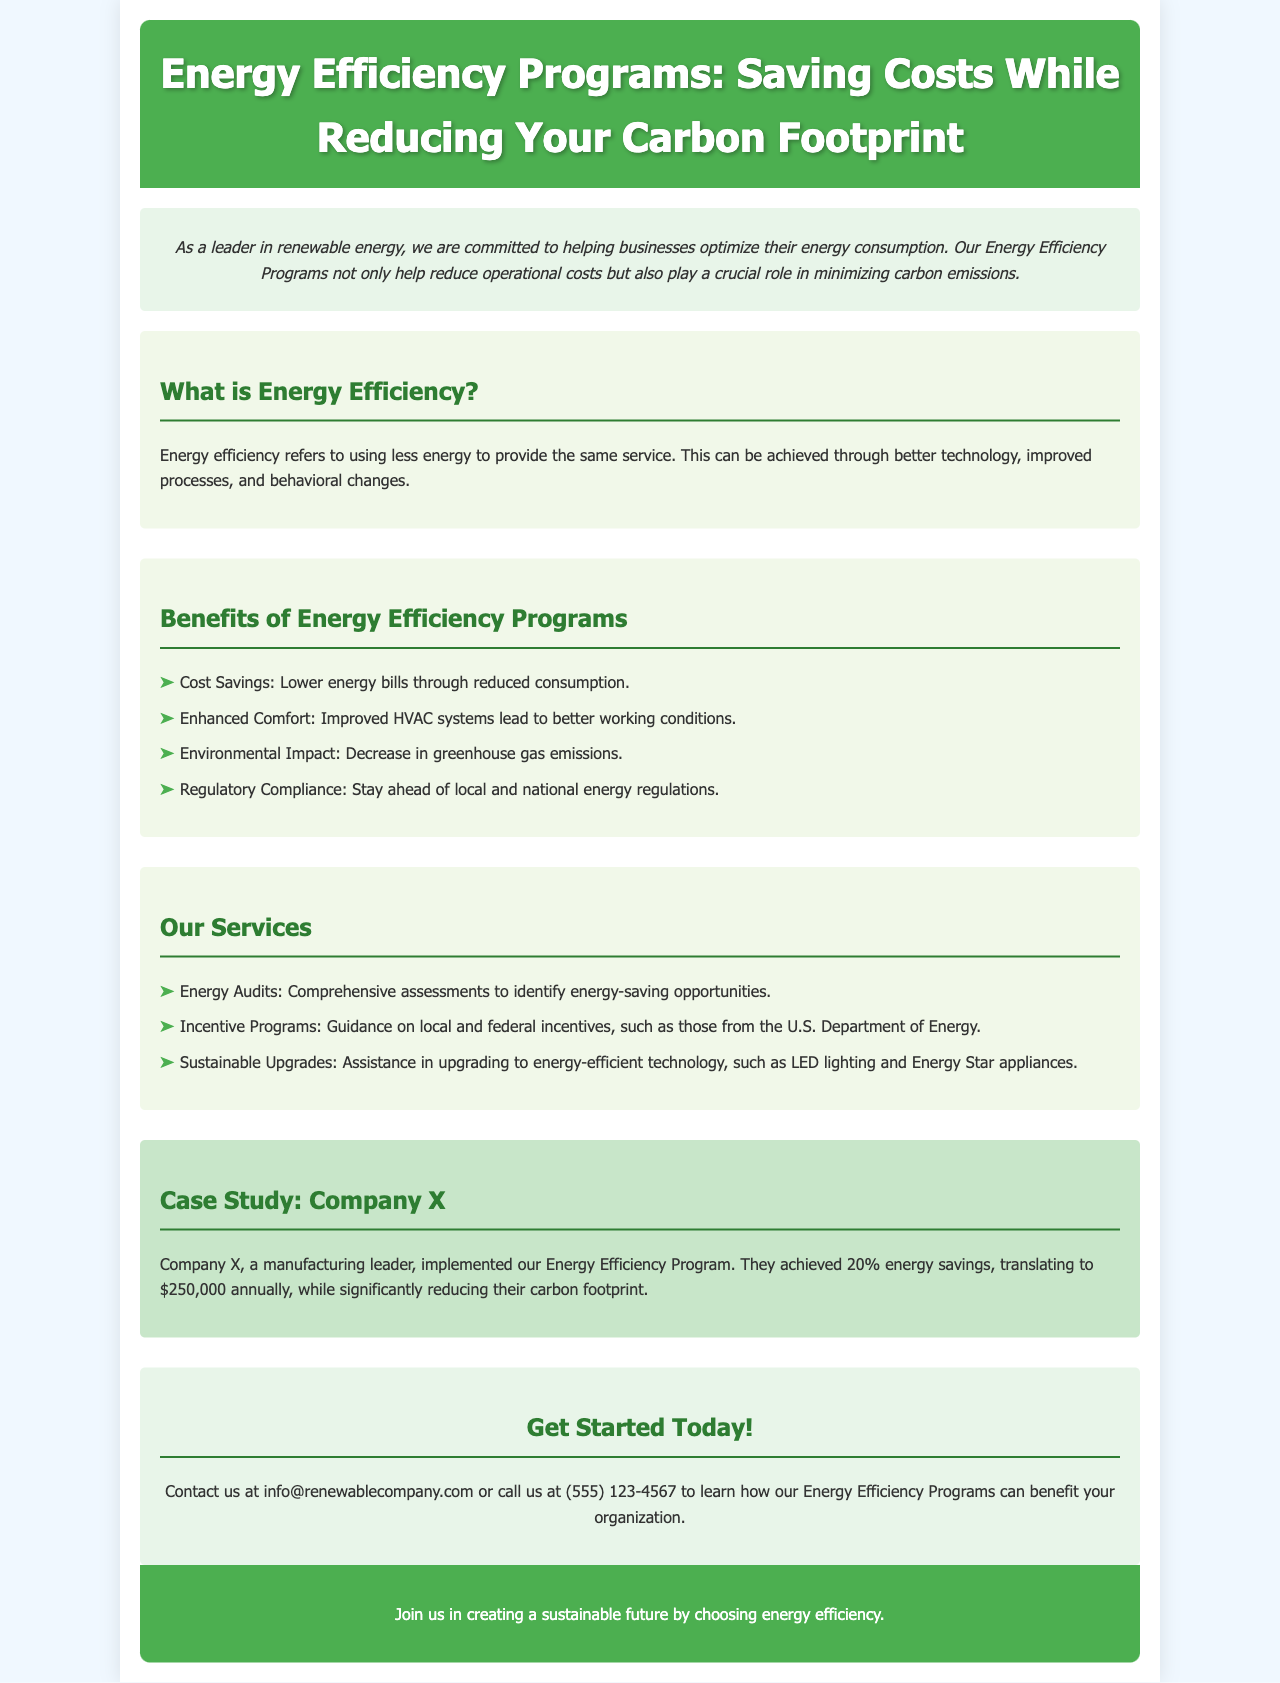What are the benefits of energy efficiency programs? The benefits listed in the document include cost savings, enhanced comfort, environmental impact, and regulatory compliance.
Answer: Cost Savings, Enhanced Comfort, Environmental Impact, Regulatory Compliance What percentage of energy savings did Company X achieve? The document states that Company X achieved 20% energy savings.
Answer: 20% What is the email address provided to contact for services? The email address is found in the contact section of the document.
Answer: info@renewablecompany.com What type of audits does the company offer? Referring to the services section, the company provides Energy Audits.
Answer: Energy Audits What annual savings did Company X experience from the program? The document mentions that Company X translated their energy savings into $250,000 annually.
Answer: $250,000 How are energy efficiency programs helpful in terms of regulations? The document states that they help in staying ahead of local and national energy regulations.
Answer: Staying ahead of regulations What technology upgrades are mentioned in the services provided? The mentioned technology upgrades include LED lighting and Energy Star appliances.
Answer: LED lighting and Energy Star appliances What is the main goal of the Energy Efficiency Programs described? The main goal is to help businesses optimize their energy consumption.
Answer: Optimize energy consumption 